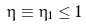Convert formula to latex. <formula><loc_0><loc_0><loc_500><loc_500>\eta \equiv \eta _ { 1 } \leq 1</formula> 